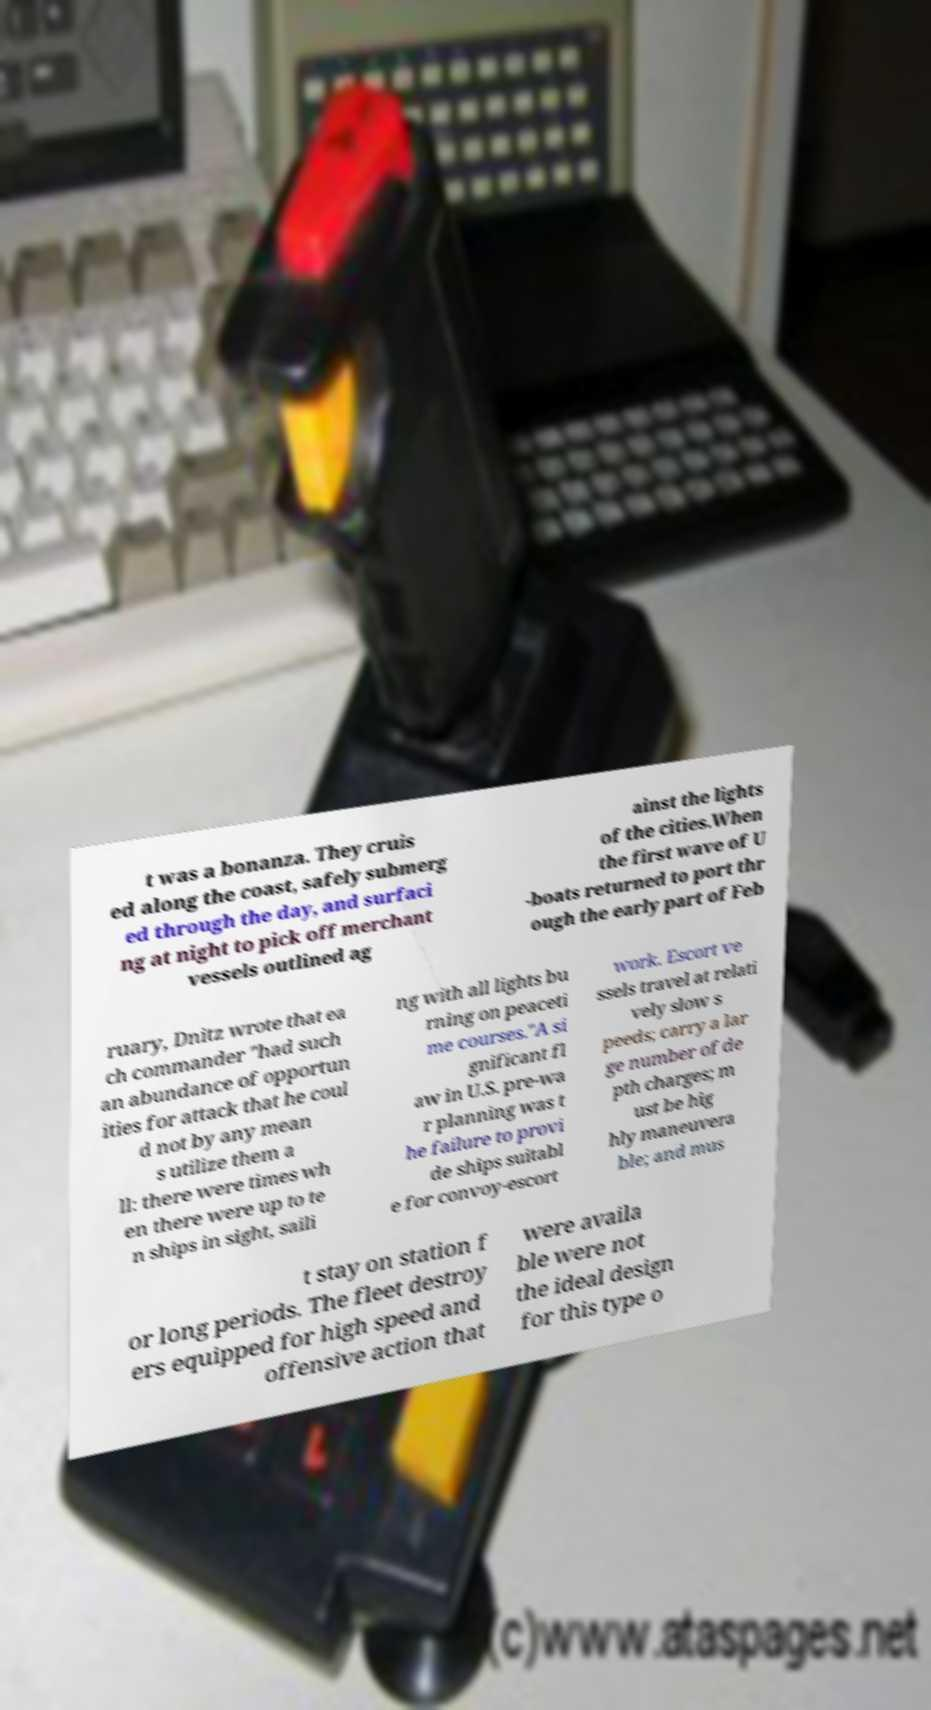For documentation purposes, I need the text within this image transcribed. Could you provide that? t was a bonanza. They cruis ed along the coast, safely submerg ed through the day, and surfaci ng at night to pick off merchant vessels outlined ag ainst the lights of the cities.When the first wave of U -boats returned to port thr ough the early part of Feb ruary, Dnitz wrote that ea ch commander "had such an abundance of opportun ities for attack that he coul d not by any mean s utilize them a ll: there were times wh en there were up to te n ships in sight, saili ng with all lights bu rning on peaceti me courses."A si gnificant fl aw in U.S. pre-wa r planning was t he failure to provi de ships suitabl e for convoy-escort work. Escort ve ssels travel at relati vely slow s peeds; carry a lar ge number of de pth charges; m ust be hig hly maneuvera ble; and mus t stay on station f or long periods. The fleet destroy ers equipped for high speed and offensive action that were availa ble were not the ideal design for this type o 